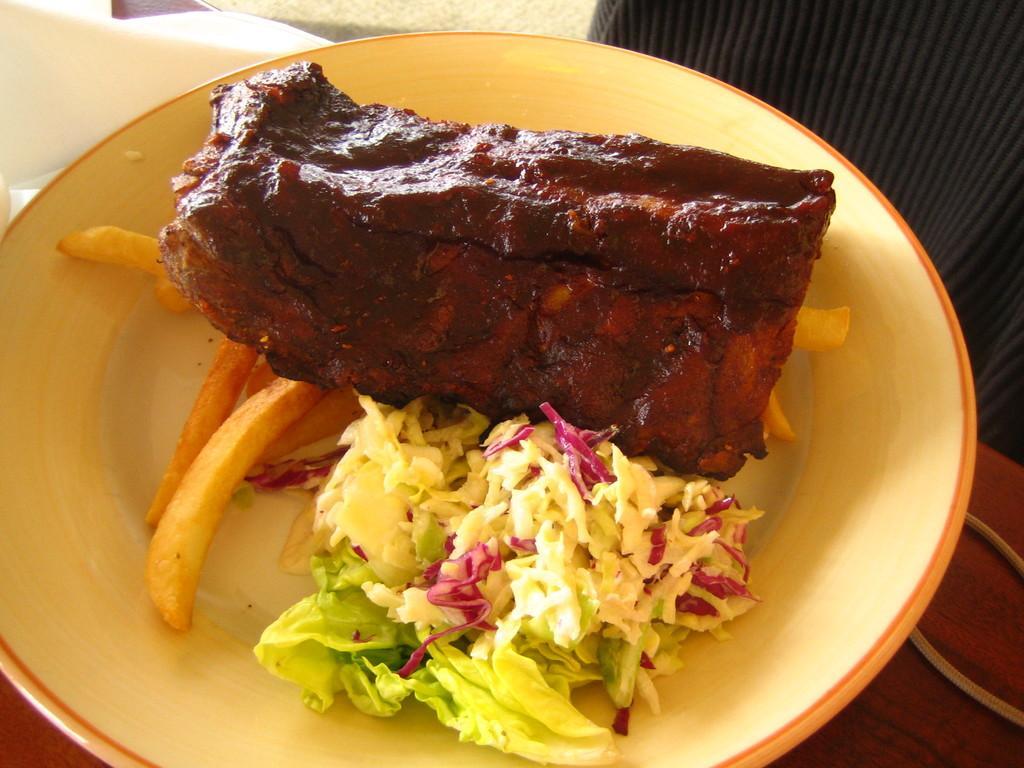In one or two sentences, can you explain what this image depicts? In this picture there are different food items on the plate. At the bottom it looks like a table and there is a cloth and plate on the table. At the back it looks like a chair. At the top it looks like a mat. 